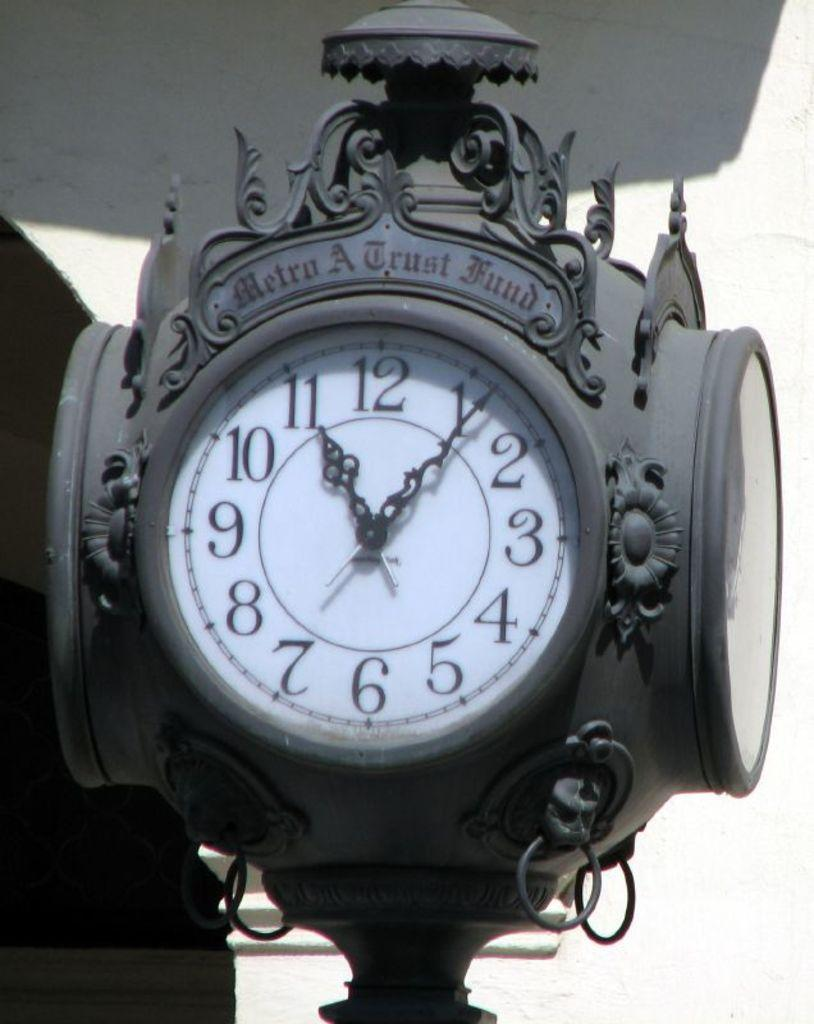<image>
Write a terse but informative summary of the picture. the numbers 1 to 12 on the clock 